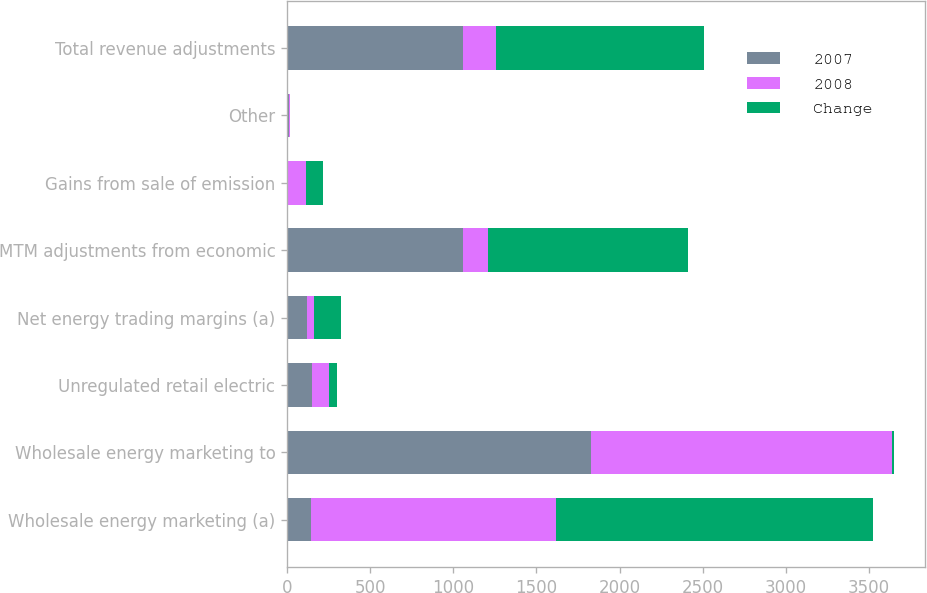Convert chart to OTSL. <chart><loc_0><loc_0><loc_500><loc_500><stacked_bar_chart><ecel><fcel>Wholesale energy marketing (a)<fcel>Wholesale energy marketing to<fcel>Unregulated retail electric<fcel>Net energy trading margins (a)<fcel>MTM adjustments from economic<fcel>Gains from sale of emission<fcel>Other<fcel>Total revenue adjustments<nl><fcel>2007<fcel>145<fcel>1826<fcel>151<fcel>121<fcel>1061<fcel>6<fcel>9<fcel>1061<nl><fcel>2008<fcel>1472<fcel>1810<fcel>102<fcel>41<fcel>145<fcel>109<fcel>8<fcel>194<nl><fcel>Change<fcel>1909<fcel>16<fcel>49<fcel>162<fcel>1206<fcel>103<fcel>1<fcel>1255<nl></chart> 